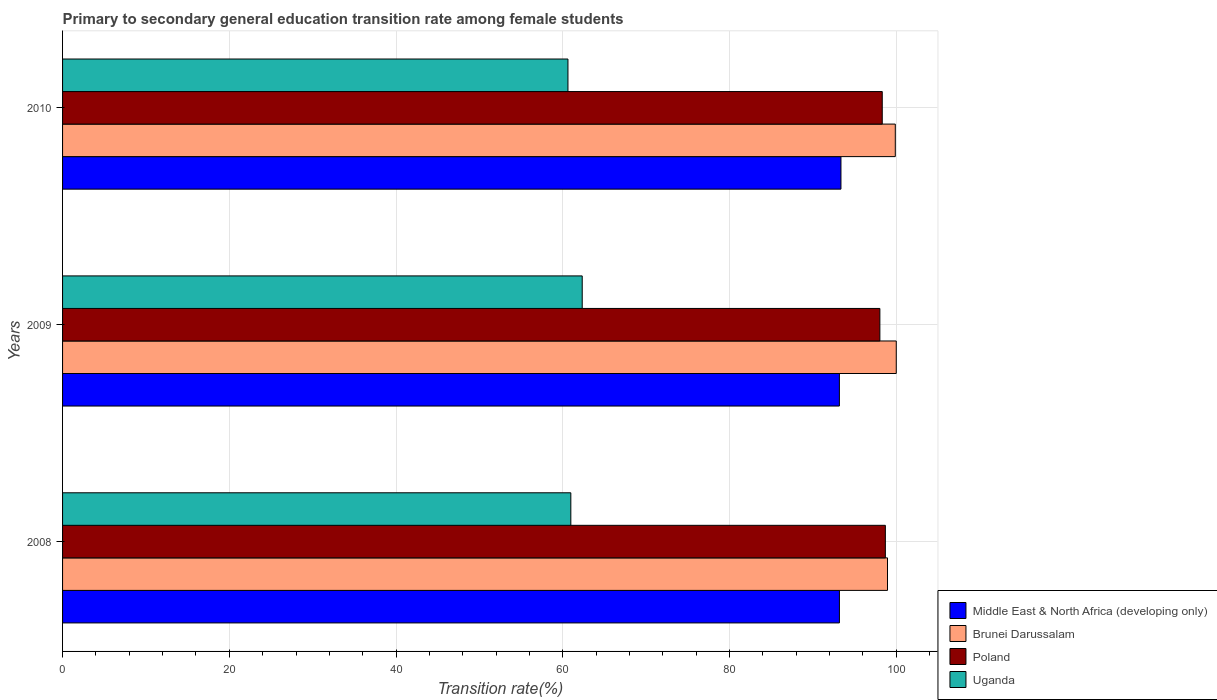How many groups of bars are there?
Make the answer very short. 3. Are the number of bars per tick equal to the number of legend labels?
Your answer should be very brief. Yes. How many bars are there on the 1st tick from the top?
Offer a terse response. 4. In how many cases, is the number of bars for a given year not equal to the number of legend labels?
Make the answer very short. 0. What is the transition rate in Brunei Darussalam in 2010?
Your answer should be compact. 99.89. Across all years, what is the maximum transition rate in Brunei Darussalam?
Your answer should be compact. 100. Across all years, what is the minimum transition rate in Uganda?
Provide a short and direct response. 60.62. What is the total transition rate in Middle East & North Africa (developing only) in the graph?
Give a very brief answer. 279.73. What is the difference between the transition rate in Uganda in 2008 and that in 2010?
Your answer should be very brief. 0.34. What is the difference between the transition rate in Poland in 2010 and the transition rate in Brunei Darussalam in 2008?
Your answer should be very brief. -0.63. What is the average transition rate in Uganda per year?
Give a very brief answer. 61.31. In the year 2008, what is the difference between the transition rate in Uganda and transition rate in Poland?
Provide a succinct answer. -37.73. What is the ratio of the transition rate in Middle East & North Africa (developing only) in 2008 to that in 2009?
Ensure brevity in your answer.  1. Is the difference between the transition rate in Uganda in 2008 and 2009 greater than the difference between the transition rate in Poland in 2008 and 2009?
Make the answer very short. No. What is the difference between the highest and the second highest transition rate in Poland?
Give a very brief answer. 0.37. What is the difference between the highest and the lowest transition rate in Poland?
Your answer should be very brief. 0.66. In how many years, is the transition rate in Brunei Darussalam greater than the average transition rate in Brunei Darussalam taken over all years?
Your answer should be very brief. 2. Is the sum of the transition rate in Poland in 2008 and 2009 greater than the maximum transition rate in Brunei Darussalam across all years?
Give a very brief answer. Yes. Is it the case that in every year, the sum of the transition rate in Middle East & North Africa (developing only) and transition rate in Uganda is greater than the sum of transition rate in Brunei Darussalam and transition rate in Poland?
Ensure brevity in your answer.  No. What does the 4th bar from the top in 2009 represents?
Your answer should be compact. Middle East & North Africa (developing only). What does the 2nd bar from the bottom in 2008 represents?
Offer a very short reply. Brunei Darussalam. Is it the case that in every year, the sum of the transition rate in Brunei Darussalam and transition rate in Uganda is greater than the transition rate in Middle East & North Africa (developing only)?
Ensure brevity in your answer.  Yes. How many bars are there?
Provide a succinct answer. 12. How many years are there in the graph?
Provide a short and direct response. 3. Are the values on the major ticks of X-axis written in scientific E-notation?
Keep it short and to the point. No. What is the title of the graph?
Your answer should be compact. Primary to secondary general education transition rate among female students. What is the label or title of the X-axis?
Keep it short and to the point. Transition rate(%). What is the Transition rate(%) in Middle East & North Africa (developing only) in 2008?
Give a very brief answer. 93.18. What is the Transition rate(%) in Brunei Darussalam in 2008?
Provide a succinct answer. 98.95. What is the Transition rate(%) of Poland in 2008?
Ensure brevity in your answer.  98.69. What is the Transition rate(%) of Uganda in 2008?
Make the answer very short. 60.96. What is the Transition rate(%) in Middle East & North Africa (developing only) in 2009?
Give a very brief answer. 93.18. What is the Transition rate(%) of Poland in 2009?
Make the answer very short. 98.04. What is the Transition rate(%) of Uganda in 2009?
Make the answer very short. 62.33. What is the Transition rate(%) in Middle East & North Africa (developing only) in 2010?
Your answer should be very brief. 93.37. What is the Transition rate(%) in Brunei Darussalam in 2010?
Your answer should be compact. 99.89. What is the Transition rate(%) in Poland in 2010?
Your answer should be compact. 98.32. What is the Transition rate(%) of Uganda in 2010?
Offer a very short reply. 60.62. Across all years, what is the maximum Transition rate(%) of Middle East & North Africa (developing only)?
Provide a succinct answer. 93.37. Across all years, what is the maximum Transition rate(%) in Brunei Darussalam?
Your answer should be compact. 100. Across all years, what is the maximum Transition rate(%) of Poland?
Offer a terse response. 98.69. Across all years, what is the maximum Transition rate(%) of Uganda?
Your answer should be compact. 62.33. Across all years, what is the minimum Transition rate(%) of Middle East & North Africa (developing only)?
Your answer should be compact. 93.18. Across all years, what is the minimum Transition rate(%) in Brunei Darussalam?
Your answer should be compact. 98.95. Across all years, what is the minimum Transition rate(%) of Poland?
Make the answer very short. 98.04. Across all years, what is the minimum Transition rate(%) in Uganda?
Your answer should be compact. 60.62. What is the total Transition rate(%) in Middle East & North Africa (developing only) in the graph?
Provide a short and direct response. 279.73. What is the total Transition rate(%) of Brunei Darussalam in the graph?
Provide a short and direct response. 298.83. What is the total Transition rate(%) in Poland in the graph?
Offer a terse response. 295.05. What is the total Transition rate(%) of Uganda in the graph?
Keep it short and to the point. 183.92. What is the difference between the Transition rate(%) in Middle East & North Africa (developing only) in 2008 and that in 2009?
Keep it short and to the point. 0. What is the difference between the Transition rate(%) in Brunei Darussalam in 2008 and that in 2009?
Ensure brevity in your answer.  -1.05. What is the difference between the Transition rate(%) of Poland in 2008 and that in 2009?
Your answer should be compact. 0.66. What is the difference between the Transition rate(%) of Uganda in 2008 and that in 2009?
Keep it short and to the point. -1.37. What is the difference between the Transition rate(%) in Middle East & North Africa (developing only) in 2008 and that in 2010?
Offer a terse response. -0.18. What is the difference between the Transition rate(%) of Brunei Darussalam in 2008 and that in 2010?
Provide a short and direct response. -0.94. What is the difference between the Transition rate(%) of Poland in 2008 and that in 2010?
Your answer should be compact. 0.37. What is the difference between the Transition rate(%) of Uganda in 2008 and that in 2010?
Keep it short and to the point. 0.34. What is the difference between the Transition rate(%) of Middle East & North Africa (developing only) in 2009 and that in 2010?
Keep it short and to the point. -0.19. What is the difference between the Transition rate(%) in Brunei Darussalam in 2009 and that in 2010?
Ensure brevity in your answer.  0.11. What is the difference between the Transition rate(%) of Poland in 2009 and that in 2010?
Keep it short and to the point. -0.28. What is the difference between the Transition rate(%) of Uganda in 2009 and that in 2010?
Provide a succinct answer. 1.71. What is the difference between the Transition rate(%) in Middle East & North Africa (developing only) in 2008 and the Transition rate(%) in Brunei Darussalam in 2009?
Your response must be concise. -6.82. What is the difference between the Transition rate(%) in Middle East & North Africa (developing only) in 2008 and the Transition rate(%) in Poland in 2009?
Give a very brief answer. -4.85. What is the difference between the Transition rate(%) of Middle East & North Africa (developing only) in 2008 and the Transition rate(%) of Uganda in 2009?
Ensure brevity in your answer.  30.85. What is the difference between the Transition rate(%) of Brunei Darussalam in 2008 and the Transition rate(%) of Poland in 2009?
Keep it short and to the point. 0.91. What is the difference between the Transition rate(%) of Brunei Darussalam in 2008 and the Transition rate(%) of Uganda in 2009?
Offer a terse response. 36.62. What is the difference between the Transition rate(%) of Poland in 2008 and the Transition rate(%) of Uganda in 2009?
Give a very brief answer. 36.36. What is the difference between the Transition rate(%) of Middle East & North Africa (developing only) in 2008 and the Transition rate(%) of Brunei Darussalam in 2010?
Ensure brevity in your answer.  -6.7. What is the difference between the Transition rate(%) of Middle East & North Africa (developing only) in 2008 and the Transition rate(%) of Poland in 2010?
Your answer should be very brief. -5.14. What is the difference between the Transition rate(%) of Middle East & North Africa (developing only) in 2008 and the Transition rate(%) of Uganda in 2010?
Provide a short and direct response. 32.56. What is the difference between the Transition rate(%) in Brunei Darussalam in 2008 and the Transition rate(%) in Poland in 2010?
Offer a very short reply. 0.63. What is the difference between the Transition rate(%) of Brunei Darussalam in 2008 and the Transition rate(%) of Uganda in 2010?
Ensure brevity in your answer.  38.33. What is the difference between the Transition rate(%) in Poland in 2008 and the Transition rate(%) in Uganda in 2010?
Keep it short and to the point. 38.07. What is the difference between the Transition rate(%) of Middle East & North Africa (developing only) in 2009 and the Transition rate(%) of Brunei Darussalam in 2010?
Provide a short and direct response. -6.71. What is the difference between the Transition rate(%) of Middle East & North Africa (developing only) in 2009 and the Transition rate(%) of Poland in 2010?
Provide a short and direct response. -5.14. What is the difference between the Transition rate(%) in Middle East & North Africa (developing only) in 2009 and the Transition rate(%) in Uganda in 2010?
Your response must be concise. 32.56. What is the difference between the Transition rate(%) of Brunei Darussalam in 2009 and the Transition rate(%) of Poland in 2010?
Your answer should be compact. 1.68. What is the difference between the Transition rate(%) in Brunei Darussalam in 2009 and the Transition rate(%) in Uganda in 2010?
Your response must be concise. 39.38. What is the difference between the Transition rate(%) in Poland in 2009 and the Transition rate(%) in Uganda in 2010?
Your answer should be very brief. 37.42. What is the average Transition rate(%) of Middle East & North Africa (developing only) per year?
Provide a succinct answer. 93.24. What is the average Transition rate(%) in Brunei Darussalam per year?
Provide a succinct answer. 99.61. What is the average Transition rate(%) in Poland per year?
Make the answer very short. 98.35. What is the average Transition rate(%) in Uganda per year?
Keep it short and to the point. 61.31. In the year 2008, what is the difference between the Transition rate(%) of Middle East & North Africa (developing only) and Transition rate(%) of Brunei Darussalam?
Make the answer very short. -5.77. In the year 2008, what is the difference between the Transition rate(%) of Middle East & North Africa (developing only) and Transition rate(%) of Poland?
Offer a very short reply. -5.51. In the year 2008, what is the difference between the Transition rate(%) in Middle East & North Africa (developing only) and Transition rate(%) in Uganda?
Make the answer very short. 32.22. In the year 2008, what is the difference between the Transition rate(%) in Brunei Darussalam and Transition rate(%) in Poland?
Offer a terse response. 0.26. In the year 2008, what is the difference between the Transition rate(%) in Brunei Darussalam and Transition rate(%) in Uganda?
Give a very brief answer. 37.98. In the year 2008, what is the difference between the Transition rate(%) of Poland and Transition rate(%) of Uganda?
Offer a terse response. 37.73. In the year 2009, what is the difference between the Transition rate(%) in Middle East & North Africa (developing only) and Transition rate(%) in Brunei Darussalam?
Your answer should be compact. -6.82. In the year 2009, what is the difference between the Transition rate(%) of Middle East & North Africa (developing only) and Transition rate(%) of Poland?
Make the answer very short. -4.86. In the year 2009, what is the difference between the Transition rate(%) of Middle East & North Africa (developing only) and Transition rate(%) of Uganda?
Keep it short and to the point. 30.85. In the year 2009, what is the difference between the Transition rate(%) in Brunei Darussalam and Transition rate(%) in Poland?
Your answer should be very brief. 1.96. In the year 2009, what is the difference between the Transition rate(%) of Brunei Darussalam and Transition rate(%) of Uganda?
Make the answer very short. 37.67. In the year 2009, what is the difference between the Transition rate(%) in Poland and Transition rate(%) in Uganda?
Ensure brevity in your answer.  35.7. In the year 2010, what is the difference between the Transition rate(%) of Middle East & North Africa (developing only) and Transition rate(%) of Brunei Darussalam?
Your answer should be very brief. -6.52. In the year 2010, what is the difference between the Transition rate(%) in Middle East & North Africa (developing only) and Transition rate(%) in Poland?
Offer a very short reply. -4.95. In the year 2010, what is the difference between the Transition rate(%) in Middle East & North Africa (developing only) and Transition rate(%) in Uganda?
Your answer should be very brief. 32.75. In the year 2010, what is the difference between the Transition rate(%) in Brunei Darussalam and Transition rate(%) in Poland?
Provide a short and direct response. 1.56. In the year 2010, what is the difference between the Transition rate(%) of Brunei Darussalam and Transition rate(%) of Uganda?
Give a very brief answer. 39.27. In the year 2010, what is the difference between the Transition rate(%) of Poland and Transition rate(%) of Uganda?
Make the answer very short. 37.7. What is the ratio of the Transition rate(%) in Brunei Darussalam in 2008 to that in 2009?
Keep it short and to the point. 0.99. What is the ratio of the Transition rate(%) in Uganda in 2008 to that in 2009?
Give a very brief answer. 0.98. What is the ratio of the Transition rate(%) in Middle East & North Africa (developing only) in 2008 to that in 2010?
Your answer should be very brief. 1. What is the ratio of the Transition rate(%) of Brunei Darussalam in 2008 to that in 2010?
Provide a short and direct response. 0.99. What is the ratio of the Transition rate(%) in Brunei Darussalam in 2009 to that in 2010?
Provide a short and direct response. 1. What is the ratio of the Transition rate(%) of Uganda in 2009 to that in 2010?
Offer a terse response. 1.03. What is the difference between the highest and the second highest Transition rate(%) in Middle East & North Africa (developing only)?
Offer a very short reply. 0.18. What is the difference between the highest and the second highest Transition rate(%) of Brunei Darussalam?
Offer a terse response. 0.11. What is the difference between the highest and the second highest Transition rate(%) in Poland?
Offer a terse response. 0.37. What is the difference between the highest and the second highest Transition rate(%) of Uganda?
Ensure brevity in your answer.  1.37. What is the difference between the highest and the lowest Transition rate(%) in Middle East & North Africa (developing only)?
Ensure brevity in your answer.  0.19. What is the difference between the highest and the lowest Transition rate(%) in Brunei Darussalam?
Provide a succinct answer. 1.05. What is the difference between the highest and the lowest Transition rate(%) in Poland?
Provide a succinct answer. 0.66. What is the difference between the highest and the lowest Transition rate(%) in Uganda?
Offer a terse response. 1.71. 